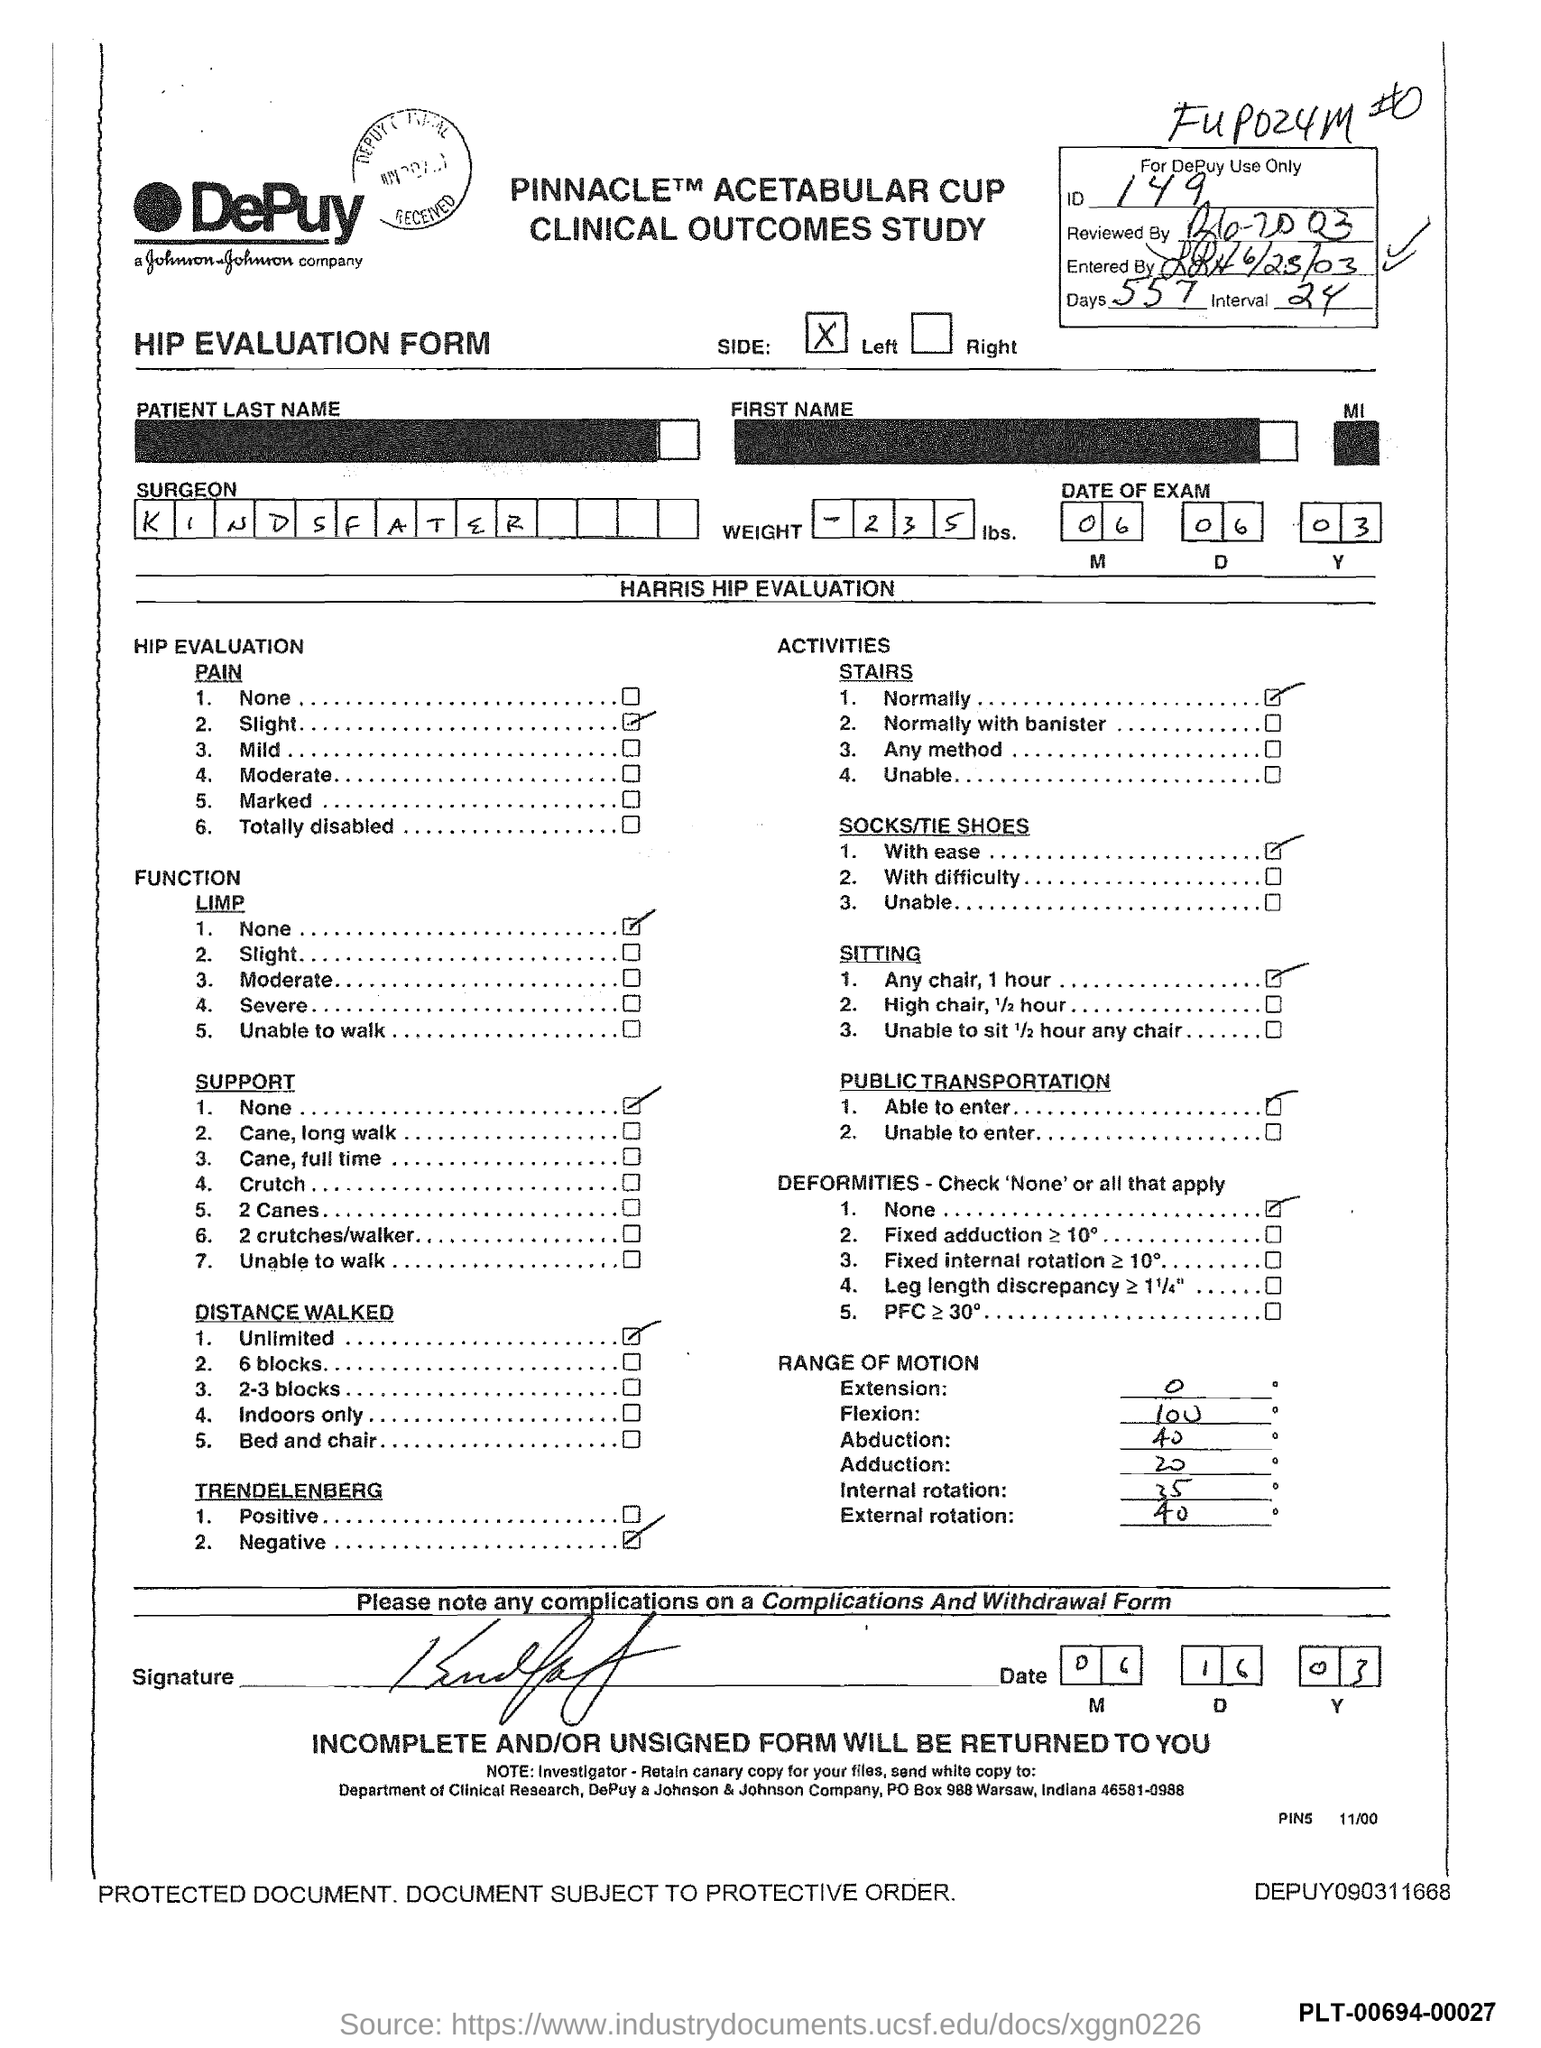Indicate a few pertinent items in this graphic. This is a HIP Evaluation Form. The ID mentioned in the form is 149. There are 557 days given in the form. The date of the exam mentioned in the form is June 6, 2003. The surgeon's name mentioned in the form is "KINDSFATER. 